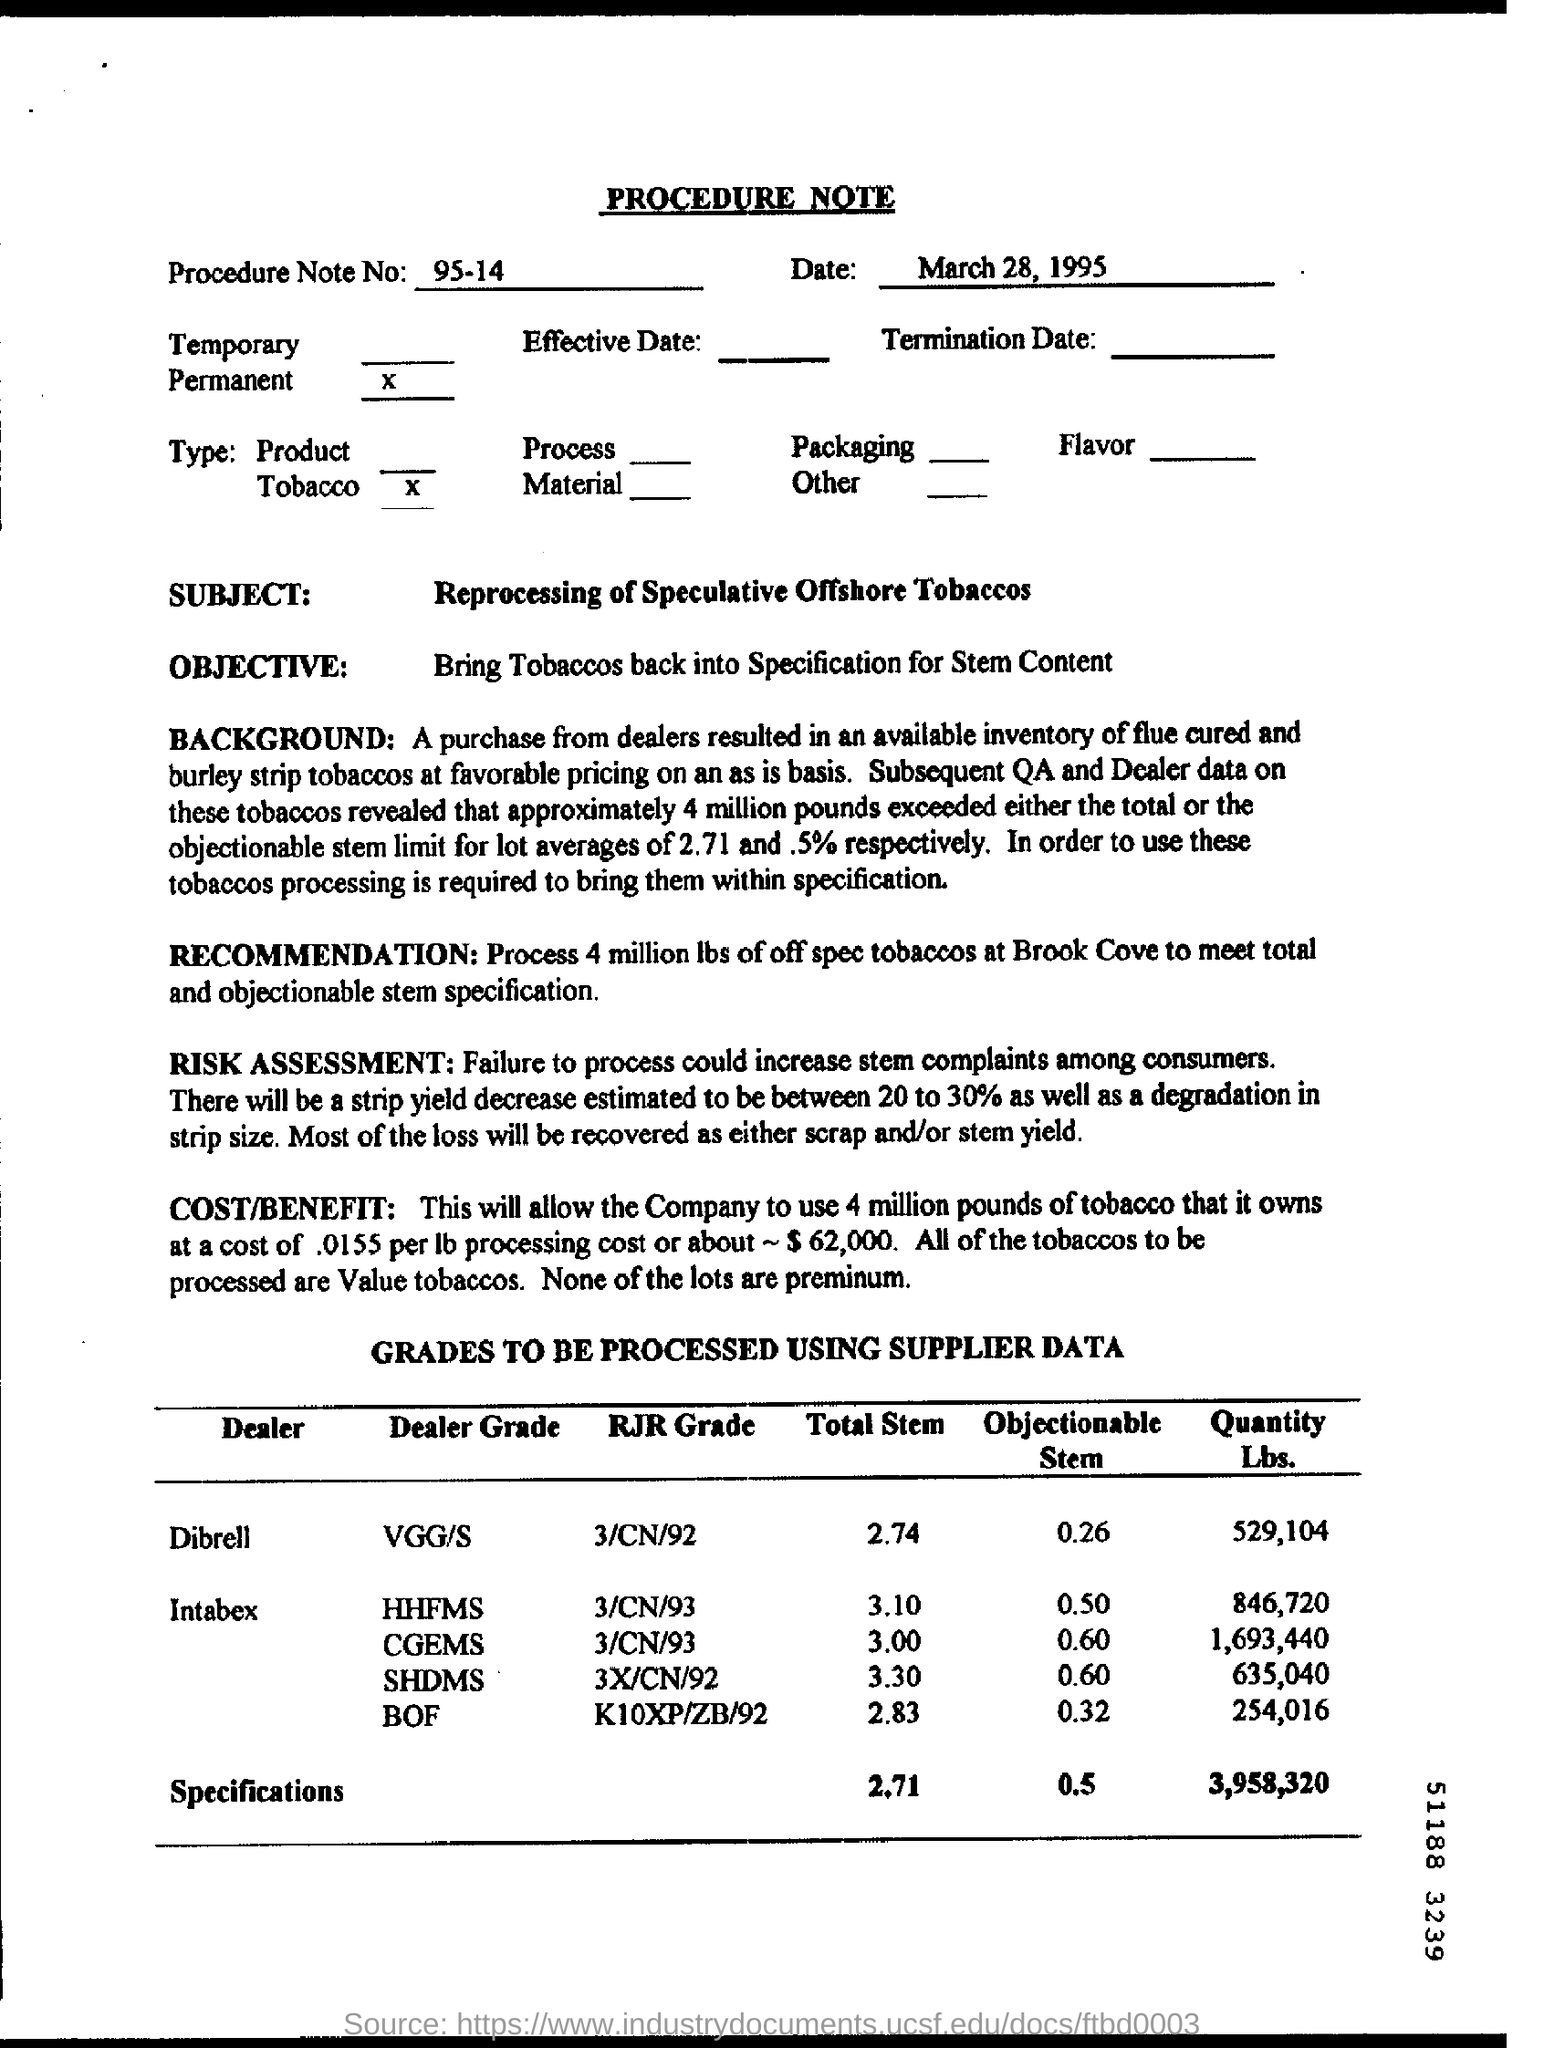What is the Procedure Note No. ? The Procedure Note No. is 95-14, dated March 28, 1995, concerning the reprocessing of speculative offshore tobaccos to meet certain specifications. 